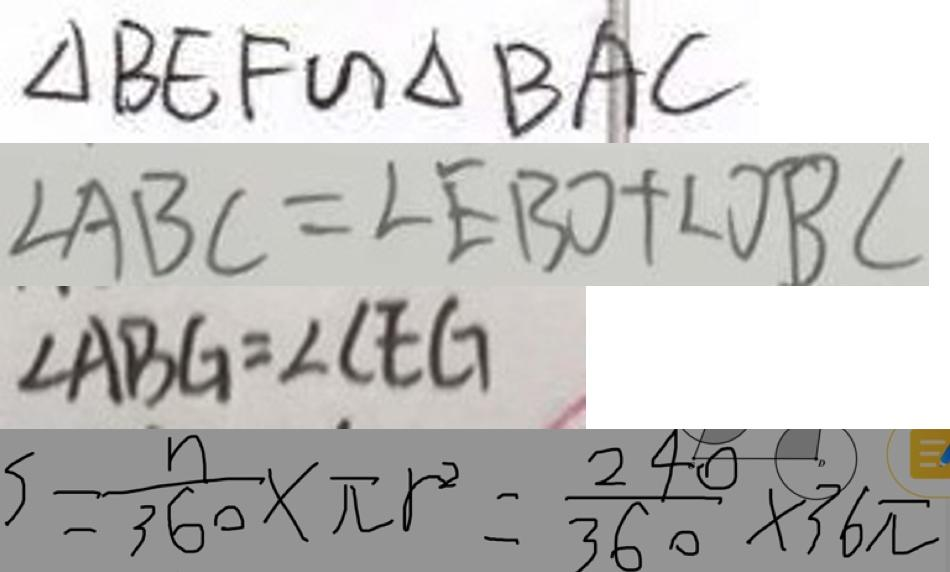Convert formula to latex. <formula><loc_0><loc_0><loc_500><loc_500>\Delta B E F \sim \Delta B A C 
 \angle A B C = \angle E B O + \angle O B C 
 \angle A B G = \angle C E G 
 S = \frac { n } { 3 6 0 } \times \pi r ^ { 2 } = \frac { 2 4 0 } { 3 6 0 } \times 3 6 \pi</formula> 